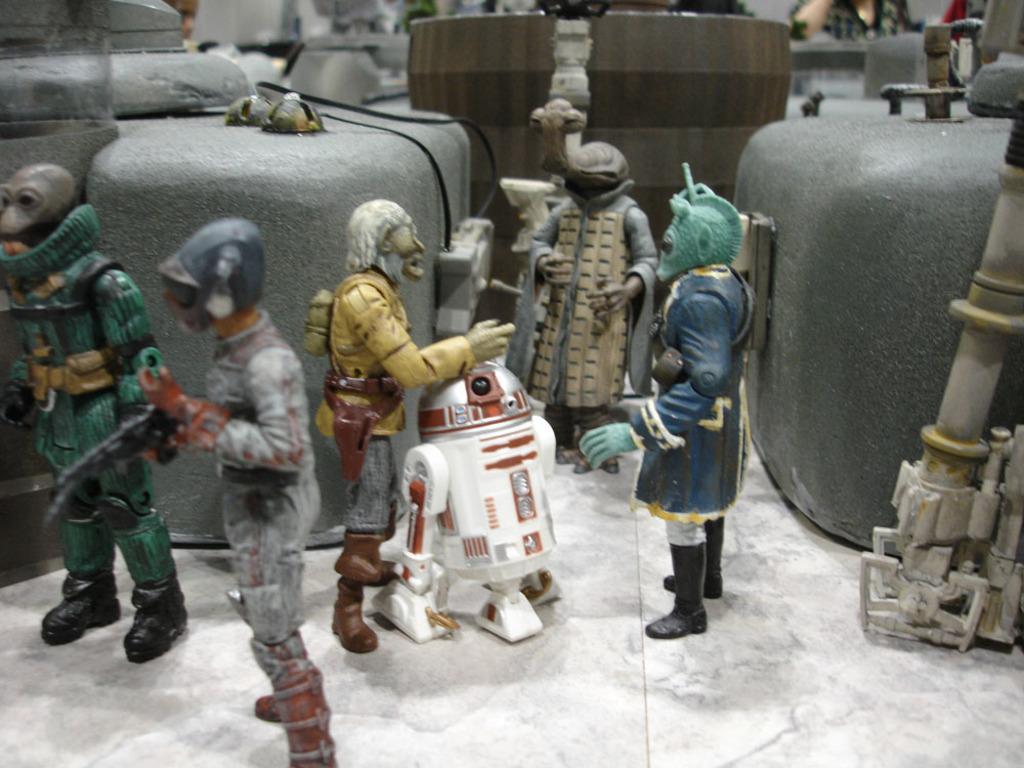How would you summarize this image in a sentence or two? In this image I can see toys in the front. There is a white robot toy in the center. There are other objects at the back. 